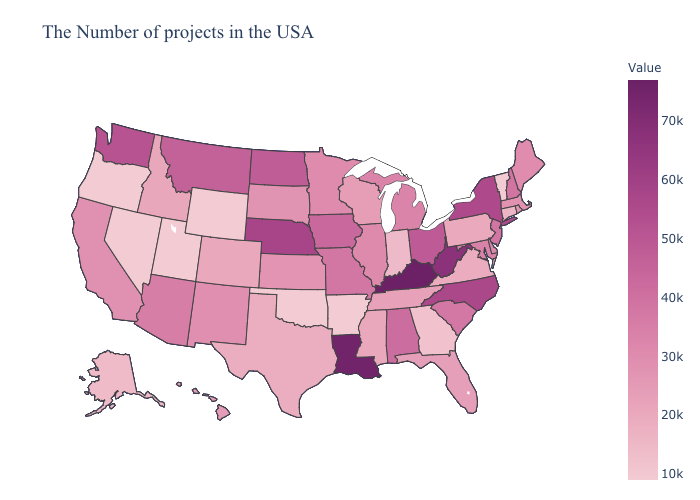Does Utah have the lowest value in the USA?
Quick response, please. Yes. Among the states that border South Dakota , does Iowa have the highest value?
Write a very short answer. No. Does Arizona have the highest value in the West?
Keep it brief. No. Among the states that border Texas , does Oklahoma have the highest value?
Keep it brief. No. Among the states that border Wisconsin , which have the lowest value?
Give a very brief answer. Minnesota. Does Nebraska have the highest value in the MidWest?
Answer briefly. Yes. Which states have the highest value in the USA?
Short answer required. Kentucky. 